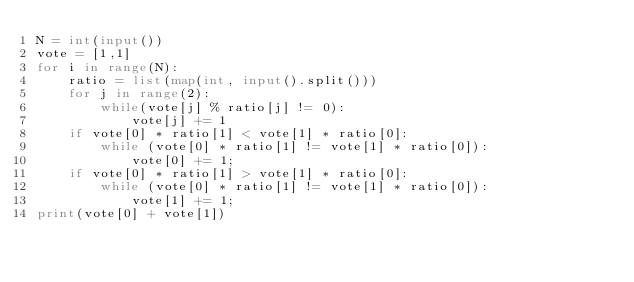Convert code to text. <code><loc_0><loc_0><loc_500><loc_500><_Python_>N = int(input())
vote = [1,1]
for i in range(N):
    ratio = list(map(int, input().split()))
    for j in range(2):
        while(vote[j] % ratio[j] != 0):
            vote[j] += 1
    if vote[0] * ratio[1] < vote[1] * ratio[0]:
        while (vote[0] * ratio[1] != vote[1] * ratio[0]):
            vote[0] += 1;
    if vote[0] * ratio[1] > vote[1] * ratio[0]:
        while (vote[0] * ratio[1] != vote[1] * ratio[0]):
            vote[1] += 1;
print(vote[0] + vote[1])</code> 